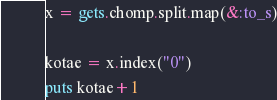<code> <loc_0><loc_0><loc_500><loc_500><_Ruby_>x = gets.chomp.split.map(&:to_s)

kotae = x.index("0")
puts kotae+1</code> 